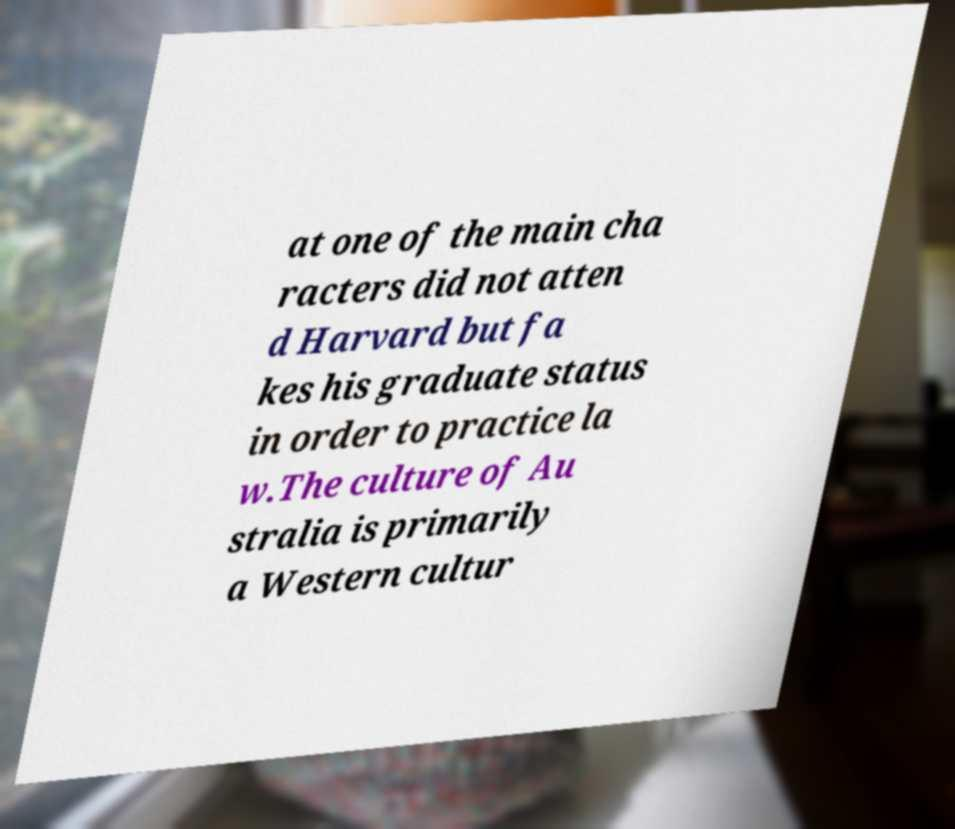Could you extract and type out the text from this image? at one of the main cha racters did not atten d Harvard but fa kes his graduate status in order to practice la w.The culture of Au stralia is primarily a Western cultur 